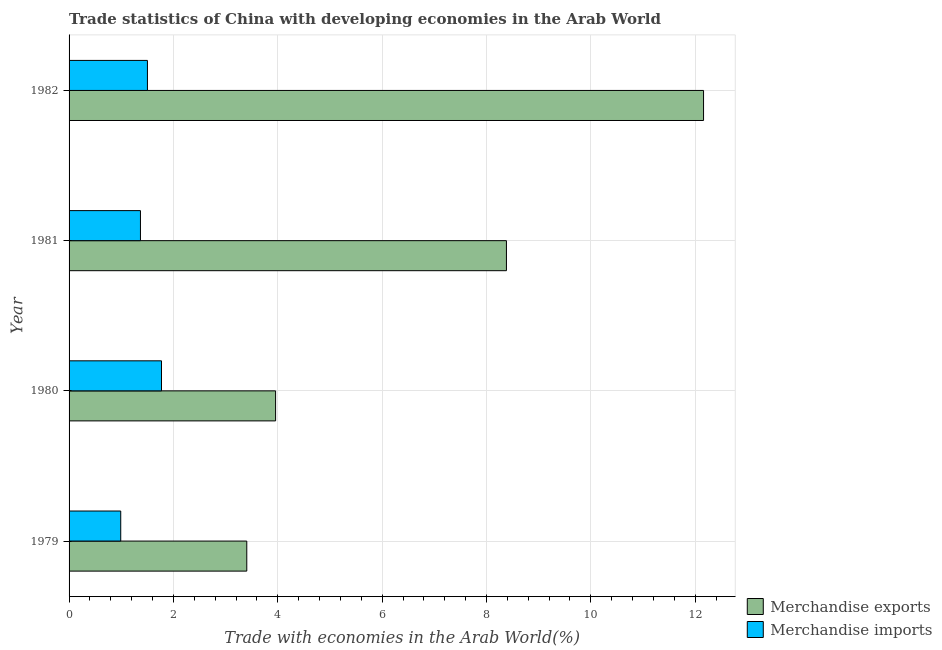How many groups of bars are there?
Give a very brief answer. 4. Are the number of bars on each tick of the Y-axis equal?
Ensure brevity in your answer.  Yes. How many bars are there on the 2nd tick from the bottom?
Provide a short and direct response. 2. What is the merchandise exports in 1981?
Provide a short and direct response. 8.38. Across all years, what is the maximum merchandise imports?
Offer a terse response. 1.77. Across all years, what is the minimum merchandise imports?
Offer a very short reply. 0.99. In which year was the merchandise exports maximum?
Your response must be concise. 1982. In which year was the merchandise exports minimum?
Offer a very short reply. 1979. What is the total merchandise imports in the graph?
Provide a succinct answer. 5.63. What is the difference between the merchandise imports in 1980 and that in 1981?
Offer a very short reply. 0.4. What is the difference between the merchandise exports in 1981 and the merchandise imports in 1980?
Offer a very short reply. 6.61. What is the average merchandise exports per year?
Offer a very short reply. 6.98. In the year 1980, what is the difference between the merchandise imports and merchandise exports?
Provide a succinct answer. -2.19. In how many years, is the merchandise exports greater than 6.8 %?
Give a very brief answer. 2. What is the ratio of the merchandise imports in 1981 to that in 1982?
Offer a terse response. 0.91. What is the difference between the highest and the second highest merchandise exports?
Offer a terse response. 3.78. What is the difference between the highest and the lowest merchandise exports?
Ensure brevity in your answer.  8.75. Is the sum of the merchandise exports in 1981 and 1982 greater than the maximum merchandise imports across all years?
Give a very brief answer. Yes. What does the 1st bar from the top in 1980 represents?
Provide a short and direct response. Merchandise imports. How many bars are there?
Give a very brief answer. 8. What is the difference between two consecutive major ticks on the X-axis?
Ensure brevity in your answer.  2. Are the values on the major ticks of X-axis written in scientific E-notation?
Keep it short and to the point. No. What is the title of the graph?
Give a very brief answer. Trade statistics of China with developing economies in the Arab World. Does "Grants" appear as one of the legend labels in the graph?
Ensure brevity in your answer.  No. What is the label or title of the X-axis?
Provide a short and direct response. Trade with economies in the Arab World(%). What is the Trade with economies in the Arab World(%) of Merchandise exports in 1979?
Offer a terse response. 3.41. What is the Trade with economies in the Arab World(%) in Merchandise imports in 1979?
Make the answer very short. 0.99. What is the Trade with economies in the Arab World(%) of Merchandise exports in 1980?
Your answer should be very brief. 3.96. What is the Trade with economies in the Arab World(%) in Merchandise imports in 1980?
Your answer should be very brief. 1.77. What is the Trade with economies in the Arab World(%) of Merchandise exports in 1981?
Provide a succinct answer. 8.38. What is the Trade with economies in the Arab World(%) of Merchandise imports in 1981?
Give a very brief answer. 1.37. What is the Trade with economies in the Arab World(%) of Merchandise exports in 1982?
Your answer should be very brief. 12.16. What is the Trade with economies in the Arab World(%) of Merchandise imports in 1982?
Your answer should be compact. 1.5. Across all years, what is the maximum Trade with economies in the Arab World(%) in Merchandise exports?
Offer a very short reply. 12.16. Across all years, what is the maximum Trade with economies in the Arab World(%) in Merchandise imports?
Your response must be concise. 1.77. Across all years, what is the minimum Trade with economies in the Arab World(%) in Merchandise exports?
Your answer should be compact. 3.41. Across all years, what is the minimum Trade with economies in the Arab World(%) in Merchandise imports?
Ensure brevity in your answer.  0.99. What is the total Trade with economies in the Arab World(%) in Merchandise exports in the graph?
Give a very brief answer. 27.91. What is the total Trade with economies in the Arab World(%) of Merchandise imports in the graph?
Provide a short and direct response. 5.63. What is the difference between the Trade with economies in the Arab World(%) of Merchandise exports in 1979 and that in 1980?
Ensure brevity in your answer.  -0.55. What is the difference between the Trade with economies in the Arab World(%) of Merchandise imports in 1979 and that in 1980?
Offer a terse response. -0.78. What is the difference between the Trade with economies in the Arab World(%) in Merchandise exports in 1979 and that in 1981?
Your response must be concise. -4.98. What is the difference between the Trade with economies in the Arab World(%) of Merchandise imports in 1979 and that in 1981?
Your answer should be compact. -0.38. What is the difference between the Trade with economies in the Arab World(%) in Merchandise exports in 1979 and that in 1982?
Keep it short and to the point. -8.75. What is the difference between the Trade with economies in the Arab World(%) of Merchandise imports in 1979 and that in 1982?
Ensure brevity in your answer.  -0.51. What is the difference between the Trade with economies in the Arab World(%) in Merchandise exports in 1980 and that in 1981?
Offer a very short reply. -4.42. What is the difference between the Trade with economies in the Arab World(%) in Merchandise imports in 1980 and that in 1981?
Provide a succinct answer. 0.4. What is the difference between the Trade with economies in the Arab World(%) in Merchandise exports in 1980 and that in 1982?
Offer a very short reply. -8.2. What is the difference between the Trade with economies in the Arab World(%) in Merchandise imports in 1980 and that in 1982?
Offer a very short reply. 0.27. What is the difference between the Trade with economies in the Arab World(%) of Merchandise exports in 1981 and that in 1982?
Offer a terse response. -3.78. What is the difference between the Trade with economies in the Arab World(%) of Merchandise imports in 1981 and that in 1982?
Your answer should be compact. -0.13. What is the difference between the Trade with economies in the Arab World(%) of Merchandise exports in 1979 and the Trade with economies in the Arab World(%) of Merchandise imports in 1980?
Your response must be concise. 1.63. What is the difference between the Trade with economies in the Arab World(%) of Merchandise exports in 1979 and the Trade with economies in the Arab World(%) of Merchandise imports in 1981?
Make the answer very short. 2.04. What is the difference between the Trade with economies in the Arab World(%) in Merchandise exports in 1979 and the Trade with economies in the Arab World(%) in Merchandise imports in 1982?
Your response must be concise. 1.9. What is the difference between the Trade with economies in the Arab World(%) of Merchandise exports in 1980 and the Trade with economies in the Arab World(%) of Merchandise imports in 1981?
Ensure brevity in your answer.  2.59. What is the difference between the Trade with economies in the Arab World(%) of Merchandise exports in 1980 and the Trade with economies in the Arab World(%) of Merchandise imports in 1982?
Keep it short and to the point. 2.46. What is the difference between the Trade with economies in the Arab World(%) of Merchandise exports in 1981 and the Trade with economies in the Arab World(%) of Merchandise imports in 1982?
Offer a terse response. 6.88. What is the average Trade with economies in the Arab World(%) of Merchandise exports per year?
Ensure brevity in your answer.  6.98. What is the average Trade with economies in the Arab World(%) of Merchandise imports per year?
Your response must be concise. 1.41. In the year 1979, what is the difference between the Trade with economies in the Arab World(%) in Merchandise exports and Trade with economies in the Arab World(%) in Merchandise imports?
Ensure brevity in your answer.  2.42. In the year 1980, what is the difference between the Trade with economies in the Arab World(%) of Merchandise exports and Trade with economies in the Arab World(%) of Merchandise imports?
Make the answer very short. 2.19. In the year 1981, what is the difference between the Trade with economies in the Arab World(%) of Merchandise exports and Trade with economies in the Arab World(%) of Merchandise imports?
Keep it short and to the point. 7.01. In the year 1982, what is the difference between the Trade with economies in the Arab World(%) of Merchandise exports and Trade with economies in the Arab World(%) of Merchandise imports?
Provide a short and direct response. 10.66. What is the ratio of the Trade with economies in the Arab World(%) in Merchandise exports in 1979 to that in 1980?
Keep it short and to the point. 0.86. What is the ratio of the Trade with economies in the Arab World(%) of Merchandise imports in 1979 to that in 1980?
Give a very brief answer. 0.56. What is the ratio of the Trade with economies in the Arab World(%) in Merchandise exports in 1979 to that in 1981?
Ensure brevity in your answer.  0.41. What is the ratio of the Trade with economies in the Arab World(%) of Merchandise imports in 1979 to that in 1981?
Your response must be concise. 0.72. What is the ratio of the Trade with economies in the Arab World(%) of Merchandise exports in 1979 to that in 1982?
Your answer should be very brief. 0.28. What is the ratio of the Trade with economies in the Arab World(%) of Merchandise imports in 1979 to that in 1982?
Keep it short and to the point. 0.66. What is the ratio of the Trade with economies in the Arab World(%) of Merchandise exports in 1980 to that in 1981?
Offer a very short reply. 0.47. What is the ratio of the Trade with economies in the Arab World(%) of Merchandise imports in 1980 to that in 1981?
Give a very brief answer. 1.29. What is the ratio of the Trade with economies in the Arab World(%) in Merchandise exports in 1980 to that in 1982?
Give a very brief answer. 0.33. What is the ratio of the Trade with economies in the Arab World(%) in Merchandise imports in 1980 to that in 1982?
Give a very brief answer. 1.18. What is the ratio of the Trade with economies in the Arab World(%) of Merchandise exports in 1981 to that in 1982?
Your answer should be very brief. 0.69. What is the ratio of the Trade with economies in the Arab World(%) of Merchandise imports in 1981 to that in 1982?
Give a very brief answer. 0.91. What is the difference between the highest and the second highest Trade with economies in the Arab World(%) in Merchandise exports?
Your answer should be compact. 3.78. What is the difference between the highest and the second highest Trade with economies in the Arab World(%) of Merchandise imports?
Offer a terse response. 0.27. What is the difference between the highest and the lowest Trade with economies in the Arab World(%) in Merchandise exports?
Provide a short and direct response. 8.75. What is the difference between the highest and the lowest Trade with economies in the Arab World(%) of Merchandise imports?
Make the answer very short. 0.78. 